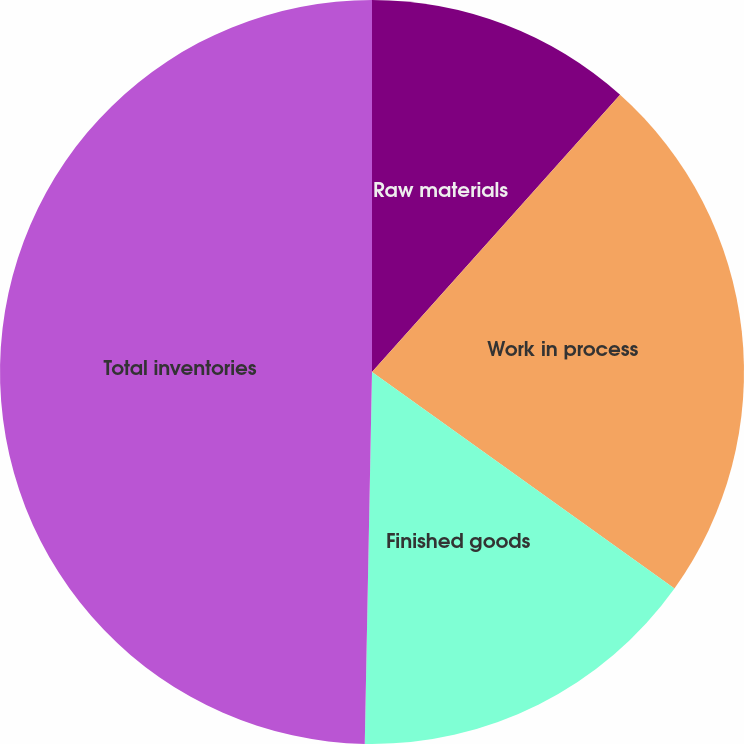Convert chart. <chart><loc_0><loc_0><loc_500><loc_500><pie_chart><fcel>Raw materials<fcel>Work in process<fcel>Finished goods<fcel>Total inventories<nl><fcel>11.62%<fcel>23.27%<fcel>15.42%<fcel>49.69%<nl></chart> 